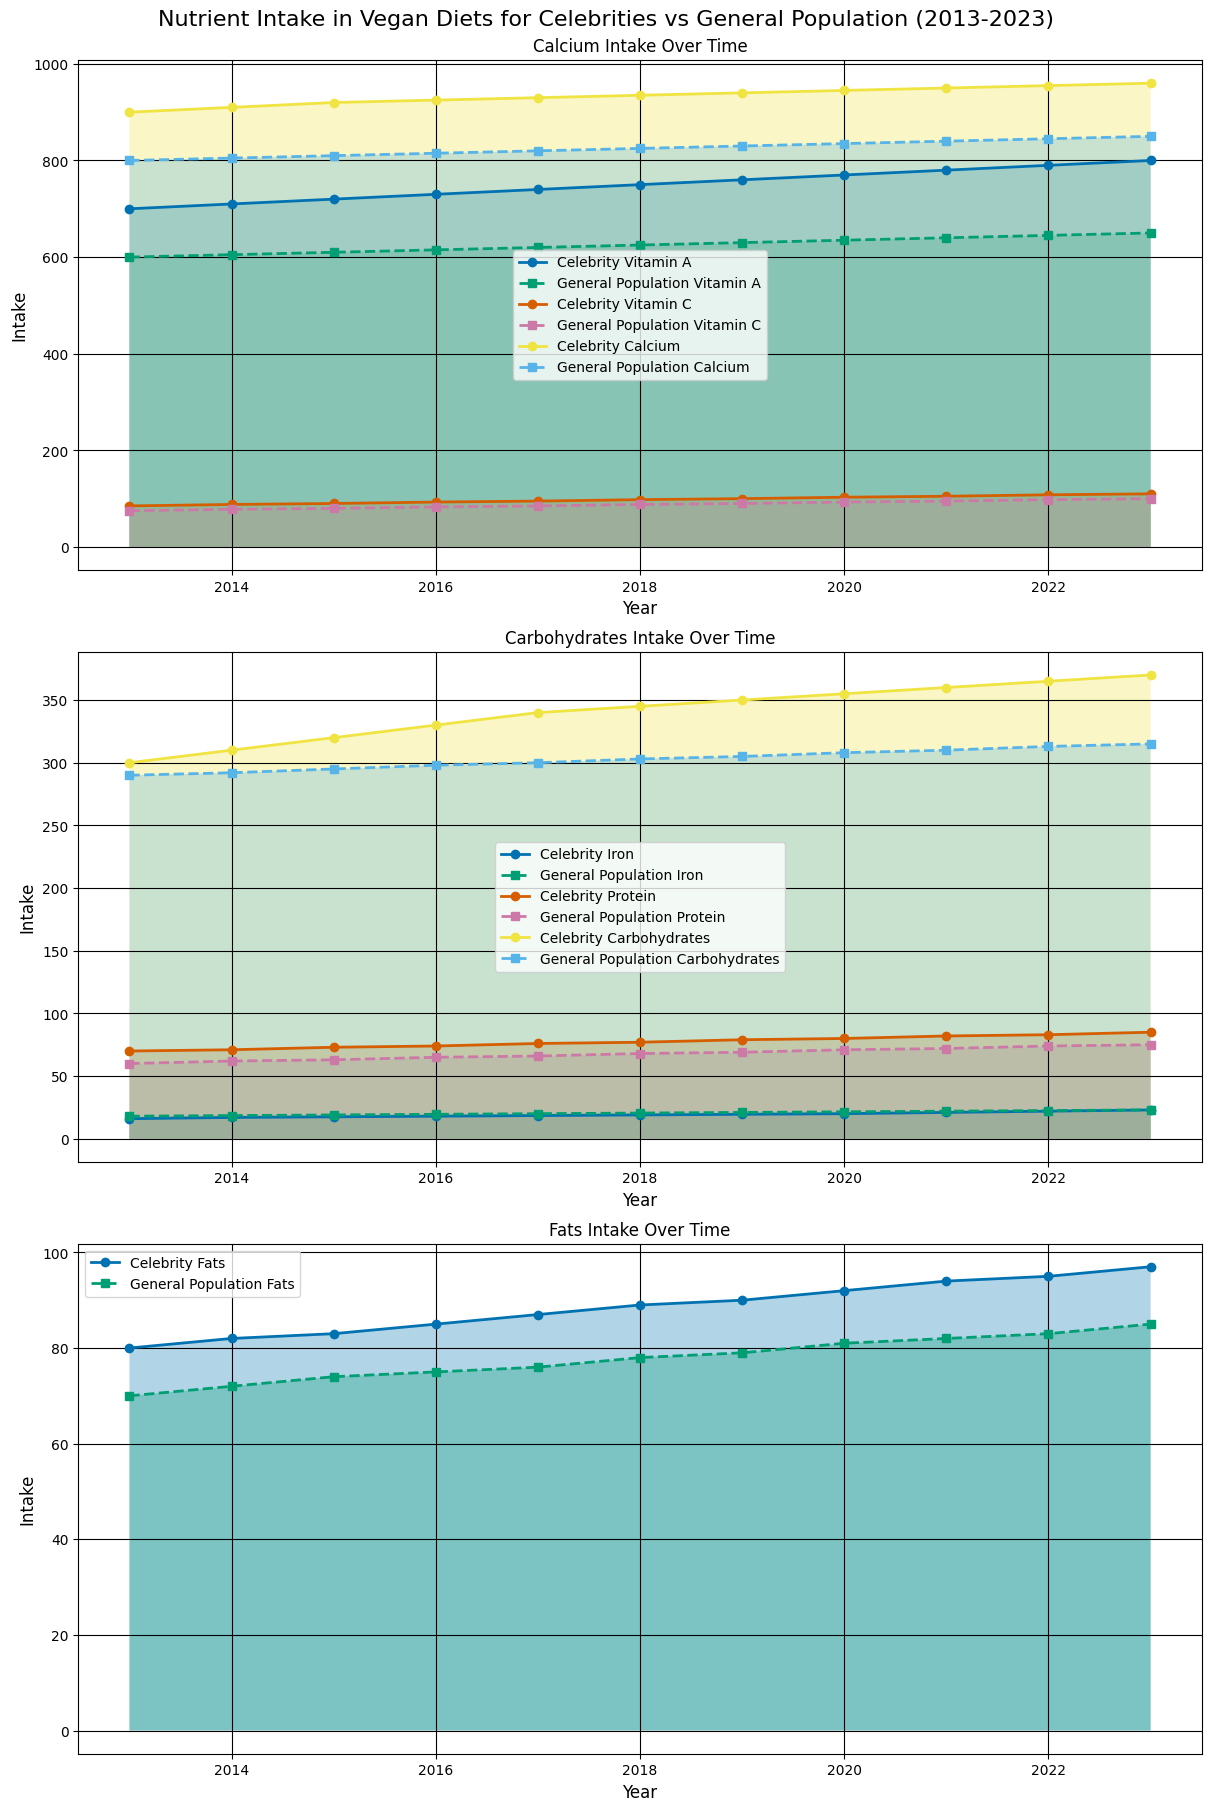What's the difference in Vitamin C intake between celebrities and the general population in 2023? To find the difference, look at the Vitamin C values for both groups in 2023. Celebrities have 110 mg, and the general population has 100 mg. The difference is 110 - 100 = 10 mg.
Answer: 10 mg Which group had a higher carbohydrate intake in 2020? Compare the carbohydrate values for both groups in 2020. Celebrities have 355 g, and the general population has 308 g. Celebrities have a higher carbohydrate intake.
Answer: Celebrities By how much did the protein intake of celebrities increase from 2013 to 2023? Look at the protein values for celebrities in 2013 and 2023. In 2013, it was 70 g, and in 2023, it was 85 g. The increase is 85 - 70 = 15 g.
Answer: 15 g Did the general population ever surpass celebrities in Iron intake? Compare the Iron intake values for both groups from 2013 to 2023. The general population has consistently higher Iron intake in all years.
Answer: Yes What was the average calcium intake for celebrities over the 10 years? Sum the calcium values for celebrities from 2013 to 2023: (900 + 910 + 920 + 925 + 930 + 935 + 940 + 945 + 950 + 955 + 960) = 9375. Divide by the number of years (11). The average calcium intake is 9375 / 11 = 852.27 mg.
Answer: 852.27 mg How does the fats intake trend for celebrities compare with the general population from 2013 to 2023? Observe the trend lines for fats intake. Celebrities show a steady increase from 80 g to 97 g, while the general population also shows an increase but at a lower rate, from 70 g to 85 g.
Answer: Celebrity fats intake increased faster What is the ratio of celebrity to general population's Vitamin A intake in 2018? Look at the Vitamin A values in 2018. Celebrity Vitamin A intake is 750 µg, and general population is 625 µg. The ratio is 750/625 = 1.2.
Answer: 1.2 Compare the carbohydrate intake of celebrities and the general population in the year with the highest recorded carbohydrate intake. The highest recorded carbohydrate intake is 370 g for celebrities in 2023. General population intake in 2023 is 315 g. Compare these two values.
Answer: Celebrities: 370 g, General Population: 315 g What is the percentage increase in Vitamin C intake for the general population from 2013 to 2023? Calculate the values for general population in 2013 and 2023. In 2013 it was 75 mg, and in 2023 it was 100 mg. The increase is 100 - 75 = 25 mg. The percentage increase is (25 / 75) * 100 = 33.33%.
Answer: 33.33% 